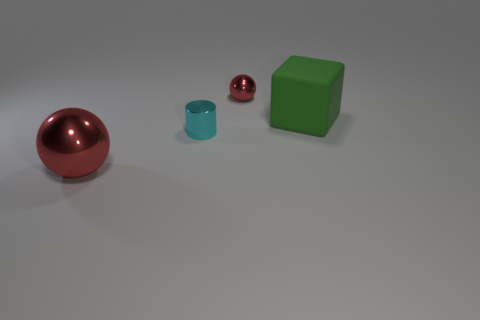What size is the other object that is the same shape as the tiny red shiny object?
Ensure brevity in your answer.  Large. Do the ball in front of the green rubber block and the large object that is behind the large red object have the same material?
Your answer should be compact. No. Is the number of small shiny spheres behind the tiny ball less than the number of green things?
Your answer should be compact. Yes. Is there any other thing that has the same shape as the big matte thing?
Offer a very short reply. No. What is the color of the tiny metallic object that is the same shape as the big metallic object?
Keep it short and to the point. Red. Do the red metallic sphere that is in front of the green matte cube and the cylinder have the same size?
Provide a succinct answer. No. What size is the metal ball that is in front of the small thing behind the green cube?
Give a very brief answer. Large. Is the material of the tiny sphere the same as the object that is in front of the tiny metallic cylinder?
Offer a terse response. Yes. Is the number of tiny spheres that are left of the tiny red object less than the number of green cubes that are behind the large block?
Offer a terse response. No. What color is the large ball that is the same material as the cylinder?
Your answer should be very brief. Red. 